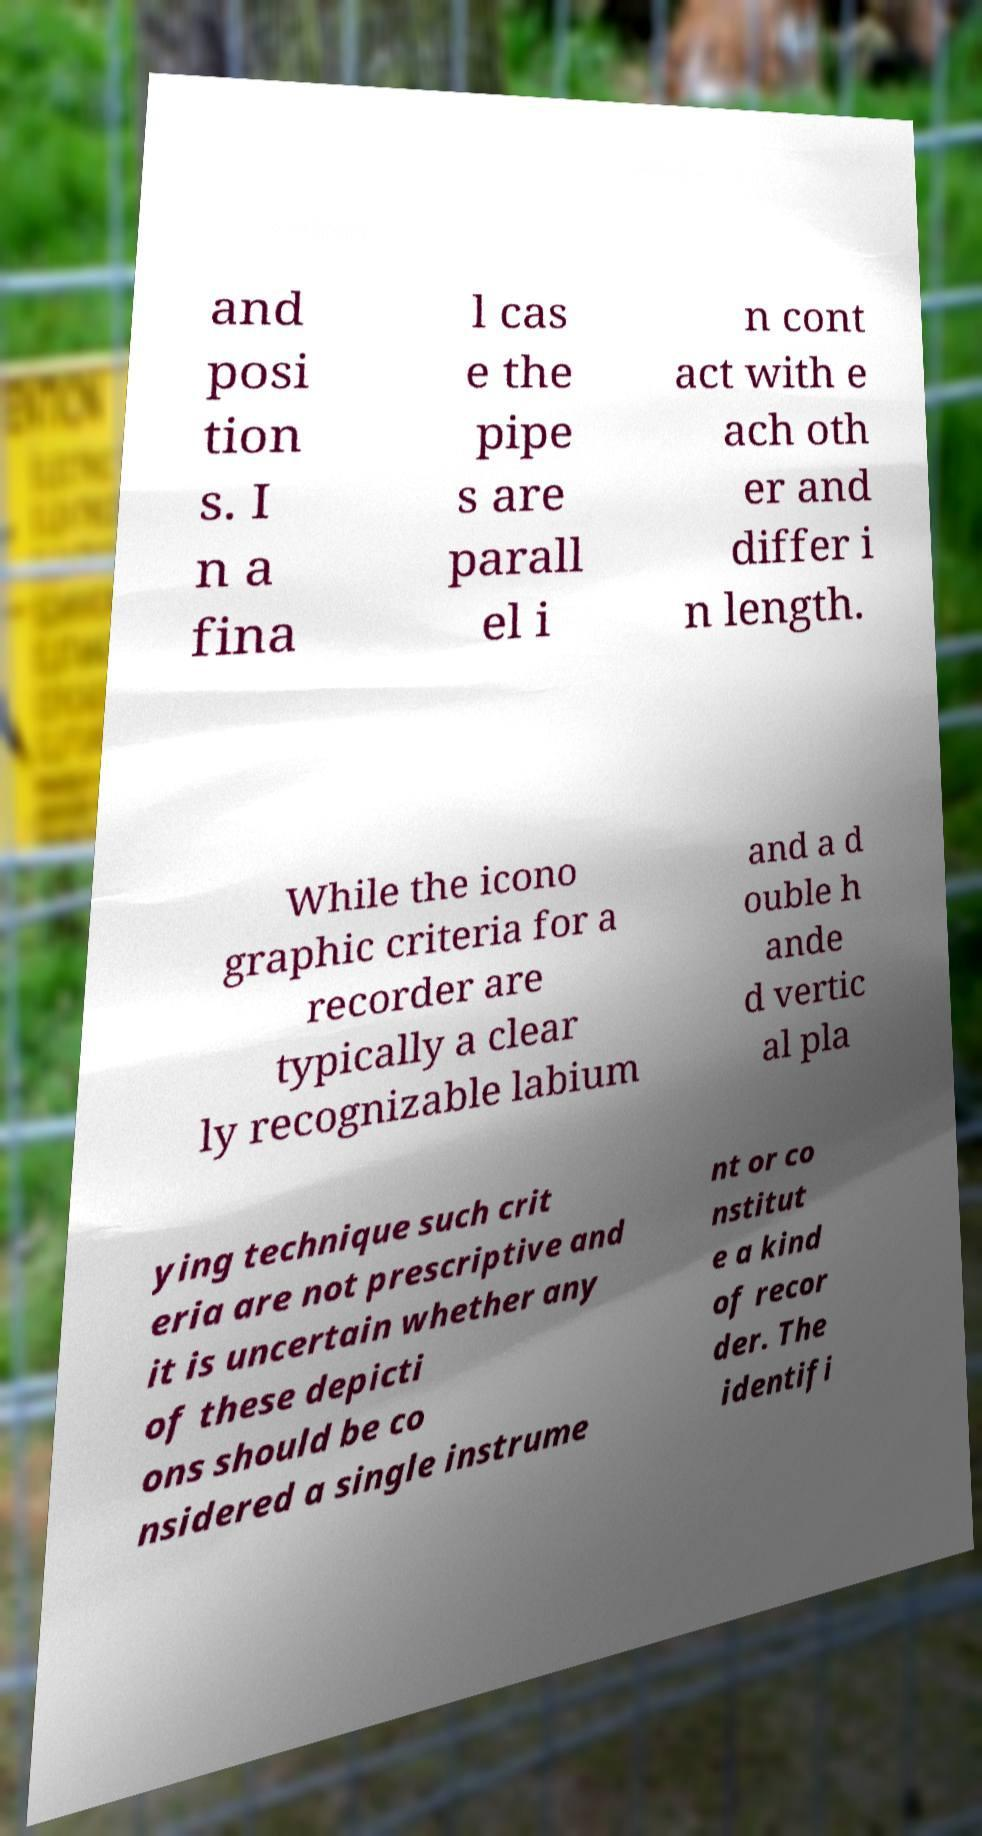Could you assist in decoding the text presented in this image and type it out clearly? and posi tion s. I n a fina l cas e the pipe s are parall el i n cont act with e ach oth er and differ i n length. While the icono graphic criteria for a recorder are typically a clear ly recognizable labium and a d ouble h ande d vertic al pla ying technique such crit eria are not prescriptive and it is uncertain whether any of these depicti ons should be co nsidered a single instrume nt or co nstitut e a kind of recor der. The identifi 